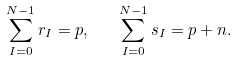Convert formula to latex. <formula><loc_0><loc_0><loc_500><loc_500>\sum _ { I = 0 } ^ { N - 1 } r _ { I } = p , \quad \sum _ { I = 0 } ^ { N - 1 } s _ { I } = p + n .</formula> 